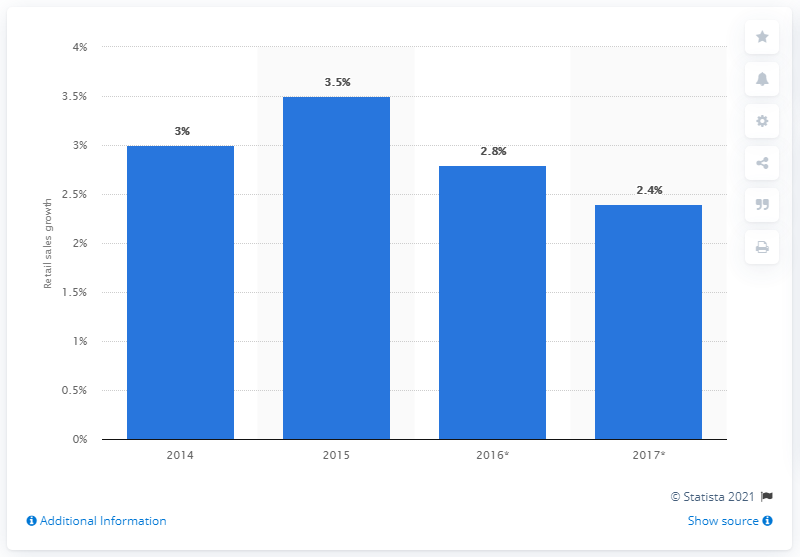List a handful of essential elements in this visual. It is estimated that non-food retail sales in the UK were expected to increase by 2.4% in 2017. According to estimates, non-food retail sales in the UK are expected to increase by 2.8% in 2016. 